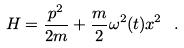Convert formula to latex. <formula><loc_0><loc_0><loc_500><loc_500>H = \frac { p ^ { 2 } } { 2 m } + \frac { m } { 2 } \omega ^ { 2 } ( t ) x ^ { 2 } \ .</formula> 